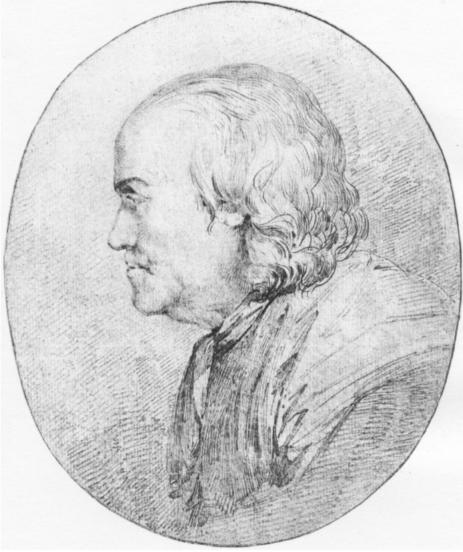What historical context or era might this sketch represent, based on the attire and style depicted? The attire and artistic style of the sketch suggest it dates back to the late 18th or early 19th century. The high-collar coat and the detailed rendering of the hair and profile are indicative of fashion trends from the Enlightenment period, a time when such portraits were popular among the European aristocracy and intellectual elite. The sober expression and dignified pose could also hint at the subject's social standing during a period characterized by intense cultural and philosophical developments. 